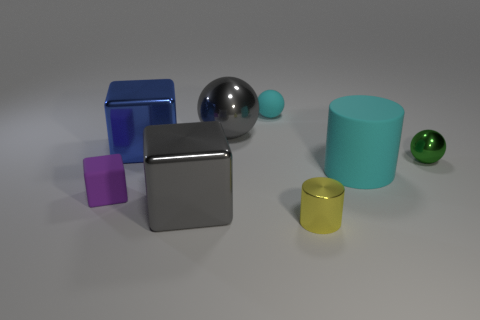Add 2 large gray spheres. How many objects exist? 10 Subtract all cubes. How many objects are left? 5 Subtract 0 purple cylinders. How many objects are left? 8 Subtract all large blue matte objects. Subtract all tiny matte cubes. How many objects are left? 7 Add 8 big gray blocks. How many big gray blocks are left? 9 Add 3 big gray shiny balls. How many big gray shiny balls exist? 4 